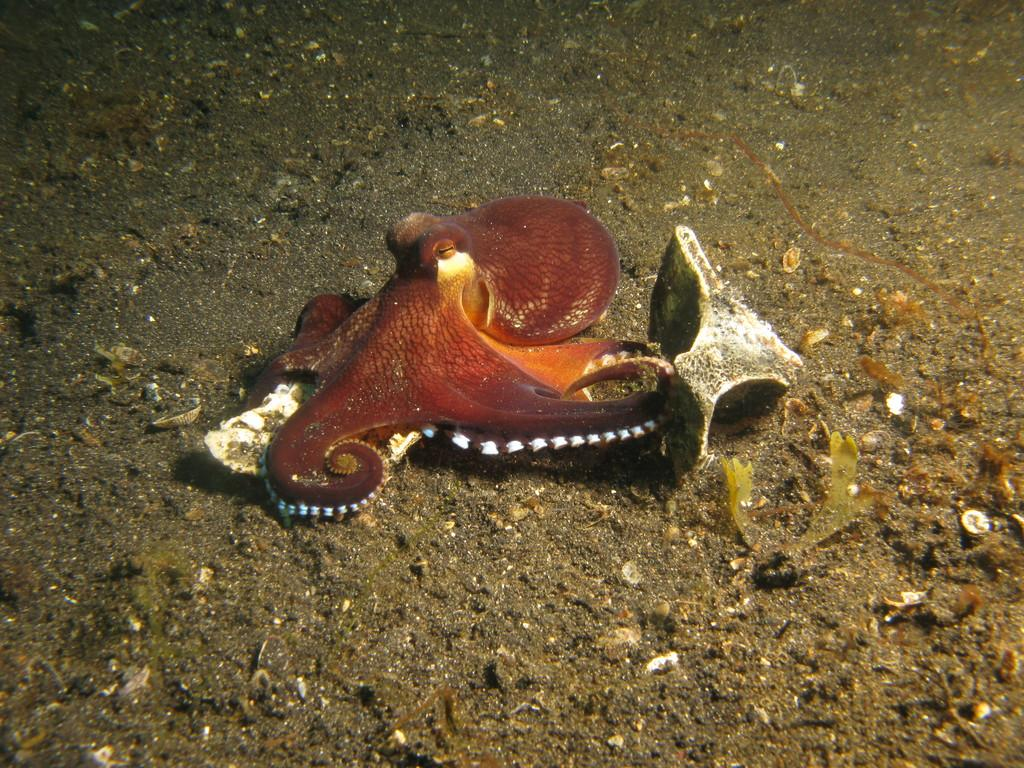What is the main subject of the picture? The main subject of the picture is an octopus. What can be seen in the background of the picture? There are leaves on a path in the background of the picture. How many kites are being flown by the octopus in the picture? There are no kites present in the image; the main subject is an octopus. What type of notebook is being used by the octopus to write in the picture? There is no notebook or writing activity depicted in the image; the main subject is an octopus. 